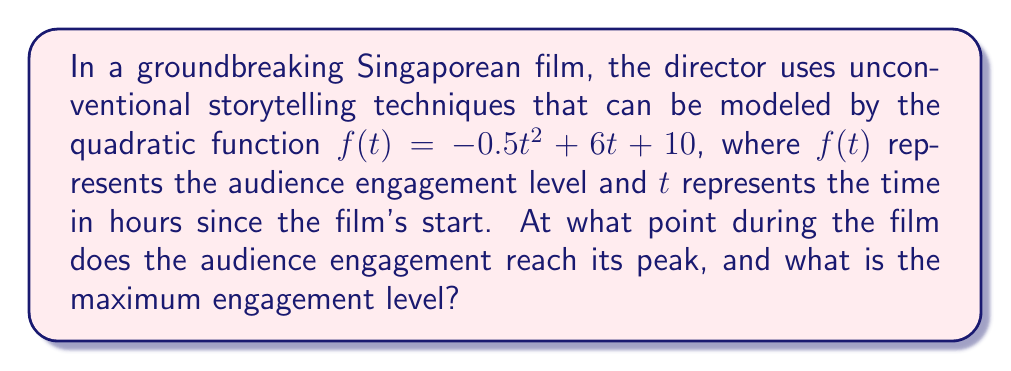What is the answer to this math problem? To solve this problem, we need to follow these steps:

1) The quadratic function is in the form $f(t) = -0.5t^2 + 6t + 10$, which is a parabola that opens downward due to the negative coefficient of $t^2$.

2) For a quadratic function $f(t) = at^2 + bt + c$, the t-coordinate of the vertex (which represents the peak of the parabola) is given by the formula $t = -\frac{b}{2a}$.

3) In this case, $a = -0.5$ and $b = 6$. Let's substitute these values:

   $t = -\frac{6}{2(-0.5)} = -\frac{6}{-1} = 6$

4) This means the audience engagement reaches its peak 6 hours into the film.

5) To find the maximum engagement level, we need to calculate $f(6)$:

   $f(6) = -0.5(6)^2 + 6(6) + 10$
   $     = -0.5(36) + 36 + 10$
   $     = -18 + 36 + 10$
   $     = 28$

Therefore, the maximum engagement level is 28.
Answer: (6, 28) 